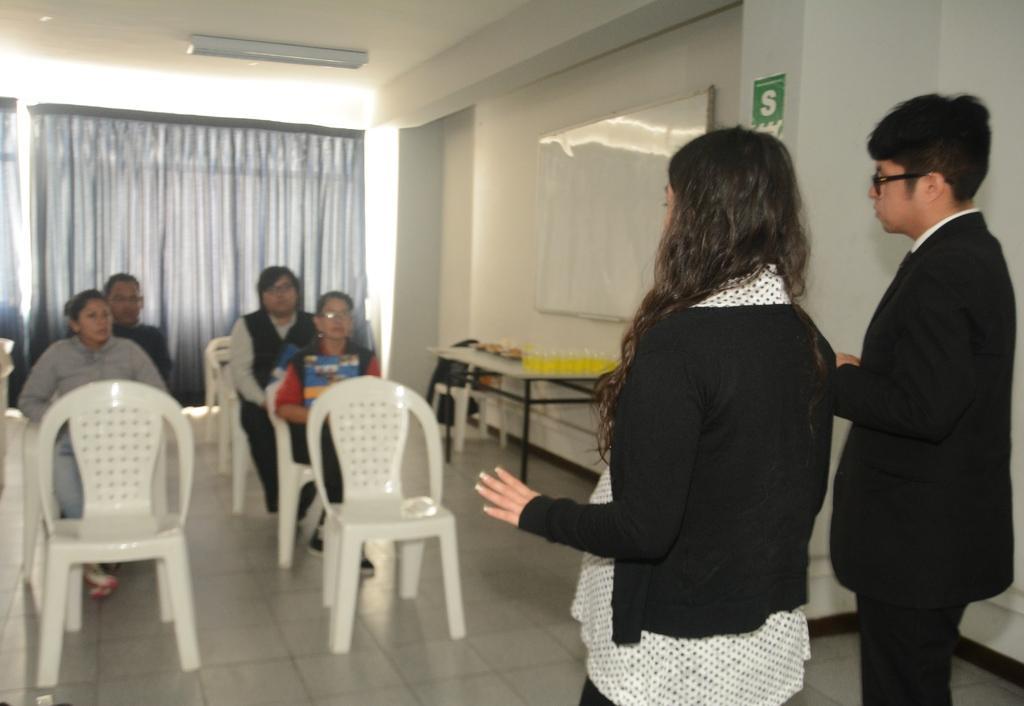In one or two sentences, can you explain what this image depicts? In this image on the right side there are two persons who are standing and on the left side there are a group of people who are sitting on a chair. And on the top there is a ceiling and light is there and on the left side there is a window and curtains are there and on the left side there is a wall and on that wall there is one board beside that board there is one table. 